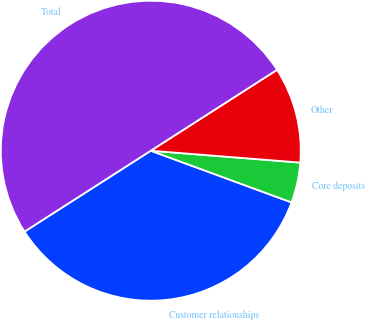Convert chart to OTSL. <chart><loc_0><loc_0><loc_500><loc_500><pie_chart><fcel>Customer relationships<fcel>Core deposits<fcel>Other<fcel>Total<nl><fcel>35.33%<fcel>4.34%<fcel>10.33%<fcel>50.0%<nl></chart> 